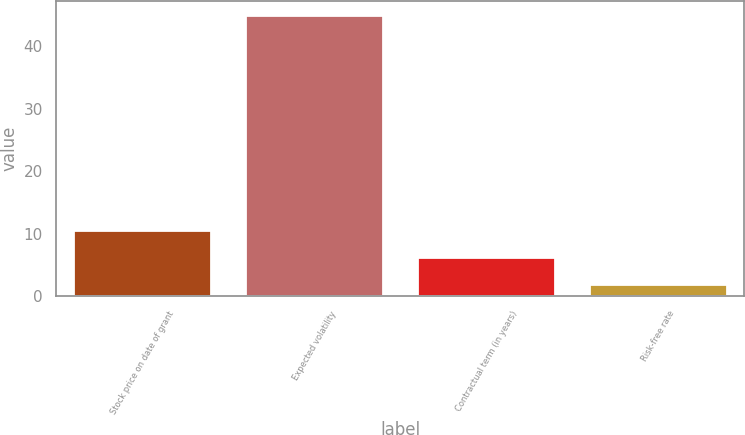Convert chart to OTSL. <chart><loc_0><loc_0><loc_500><loc_500><bar_chart><fcel>Stock price on date of grant<fcel>Expected volatility<fcel>Contractual term (in years)<fcel>Risk-free rate<nl><fcel>10.59<fcel>45<fcel>6.29<fcel>1.99<nl></chart> 